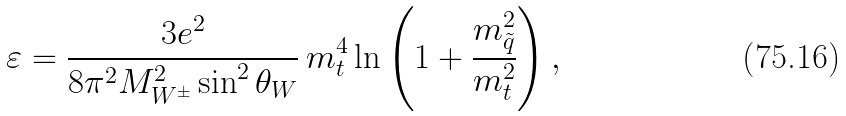Convert formula to latex. <formula><loc_0><loc_0><loc_500><loc_500>\varepsilon = \frac { 3 e ^ { 2 } } { 8 \pi ^ { 2 } M ^ { 2 } _ { W ^ { \pm } } \sin ^ { 2 } \theta _ { W } } \, m _ { t } ^ { 4 } \, { \ln } \left ( 1 + \frac { { m } ^ { 2 } _ { \tilde { q } } } { m _ { t } ^ { 2 } } \right ) ,</formula> 